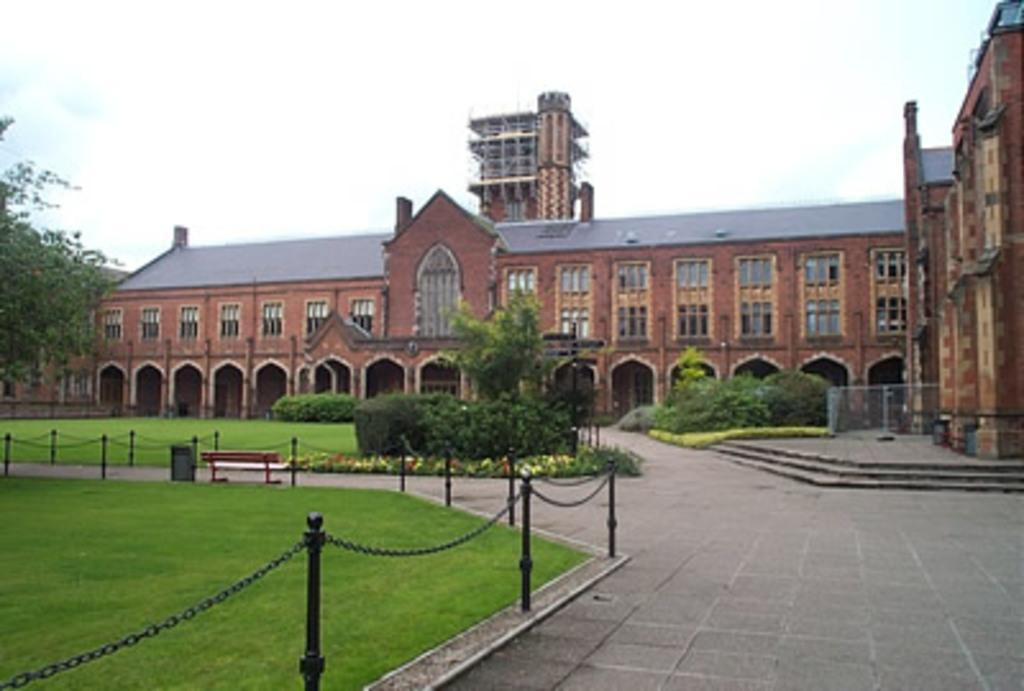What type of structures can be seen in the image? There are buildings in the image. What natural elements are present in the image? There are trees, plants, and grass on the ground in the image. What type of seating is available in the image? There is a bench in the image. What is the condition of the sky in the image? The sky is cloudy in the image. Can you see any curves in the stream that runs through the image? There is no stream present in the image; it features buildings, trees, plants, a bench, grass, and a cloudy sky. What type of transport is available for people in the image? The image does not show any transport options; it only features a bench as a seating option. 